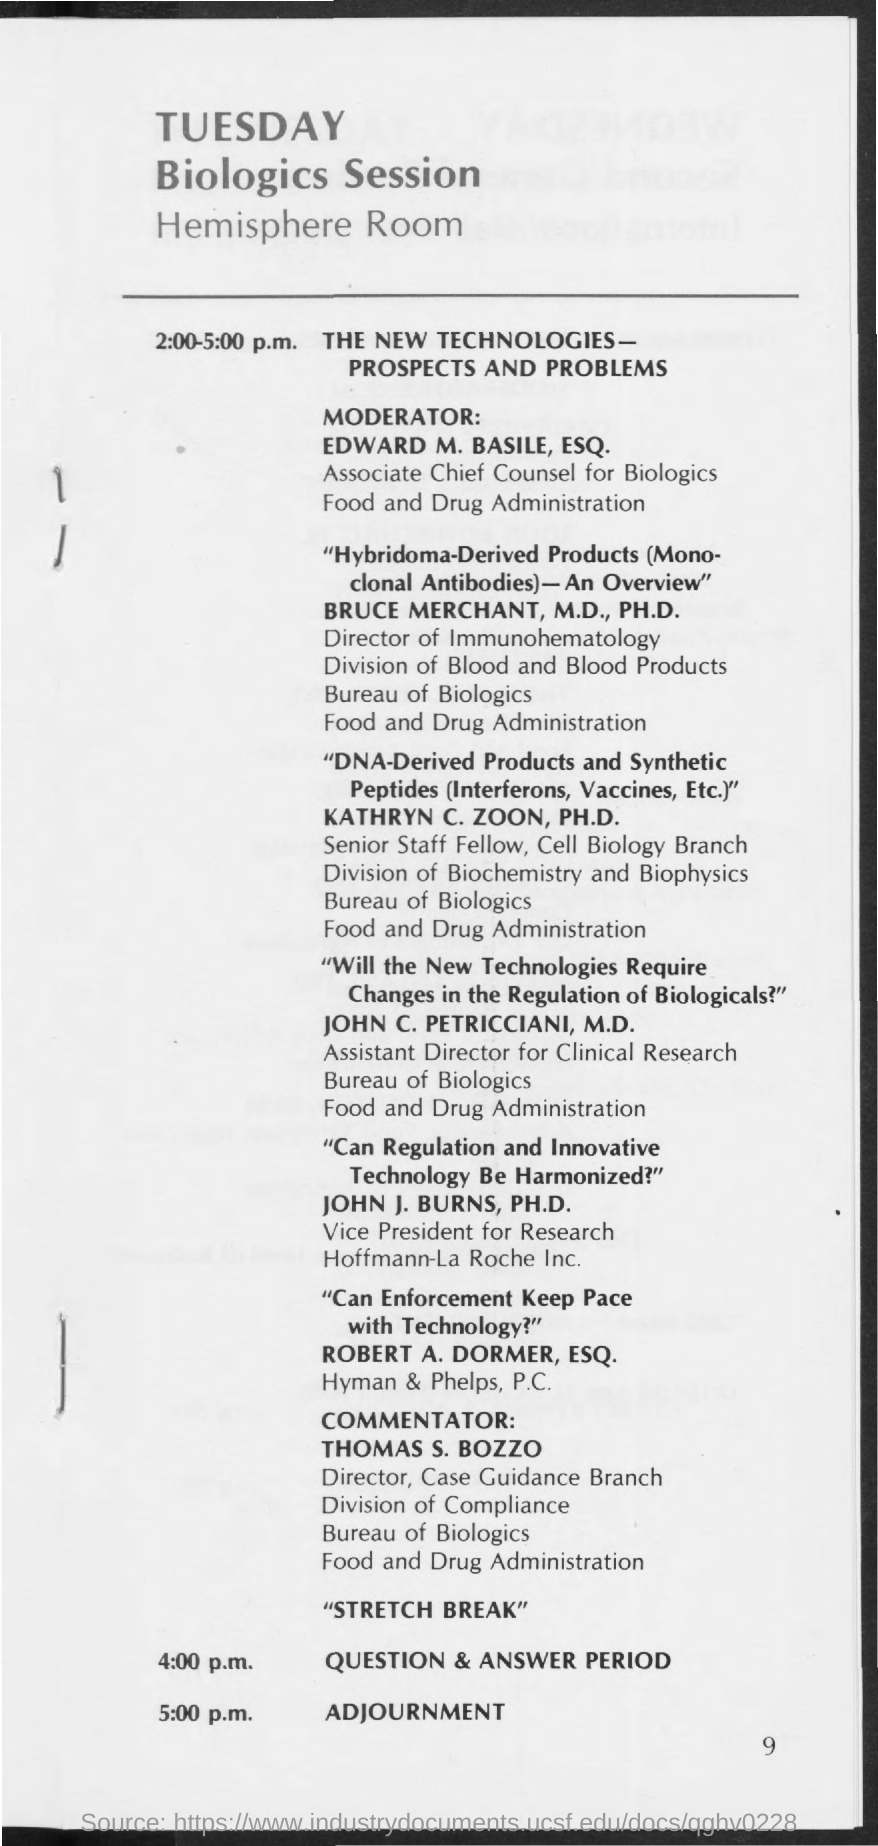Highlight a few significant elements in this photo. The adjournment is scheduled for 5:00 p.m. 